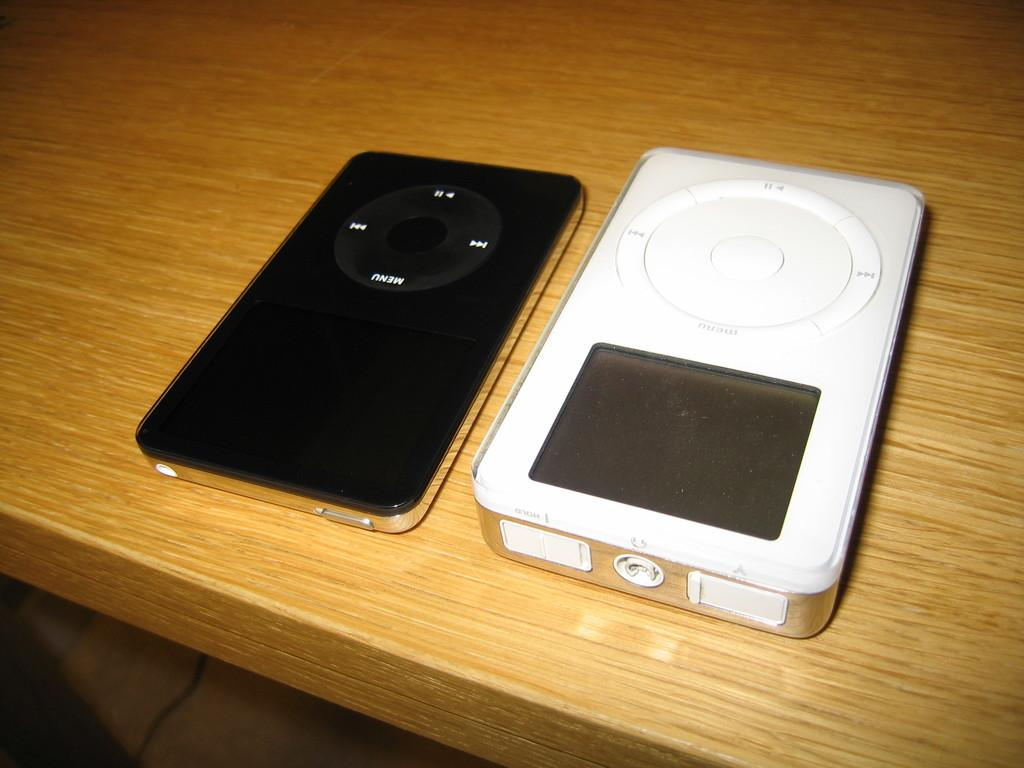What color is the electronic device on the table? The electronic device on the table is white in color. Are there any other electronic devices visible in the image? Yes, there is another electronic device in black color beside the white one. Can you see any rivers flowing near the electronic devices in the image? There is no river visible in the image; it features electronic devices on a table. Are there any flowers present in the image? There is no flower present in the image; it features electronic devices on a table. 